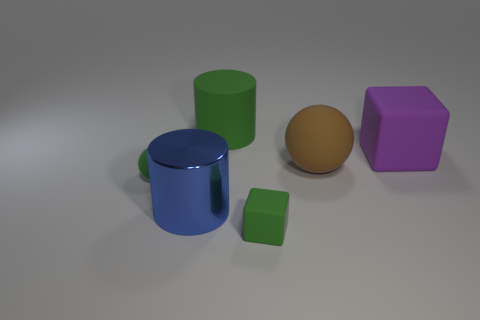Add 2 large cyan metal objects. How many objects exist? 8 Subtract all green cubes. How many cubes are left? 1 Subtract all cubes. How many objects are left? 4 Subtract 1 blocks. How many blocks are left? 1 Subtract all blue cubes. Subtract all blue cylinders. How many cubes are left? 2 Subtract all big cyan rubber spheres. Subtract all big balls. How many objects are left? 5 Add 5 tiny rubber balls. How many tiny rubber balls are left? 6 Add 3 large metallic cylinders. How many large metallic cylinders exist? 4 Subtract 0 brown blocks. How many objects are left? 6 